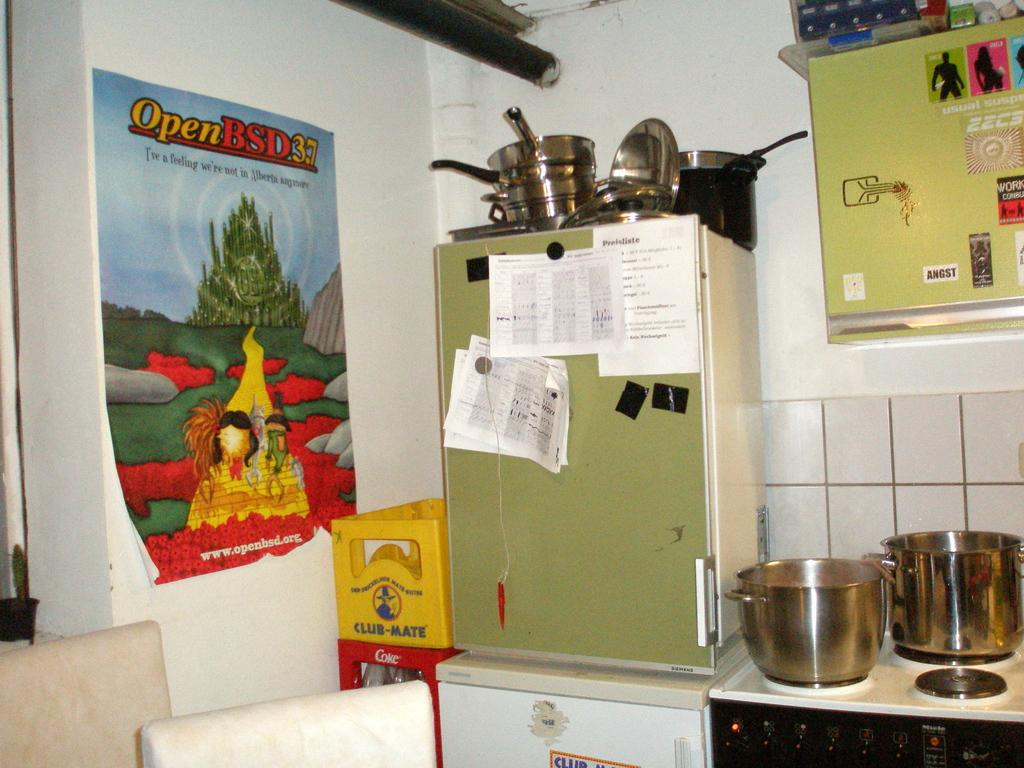<image>
Summarize the visual content of the image. a kitchen with a poster for Open BSD on the wall 